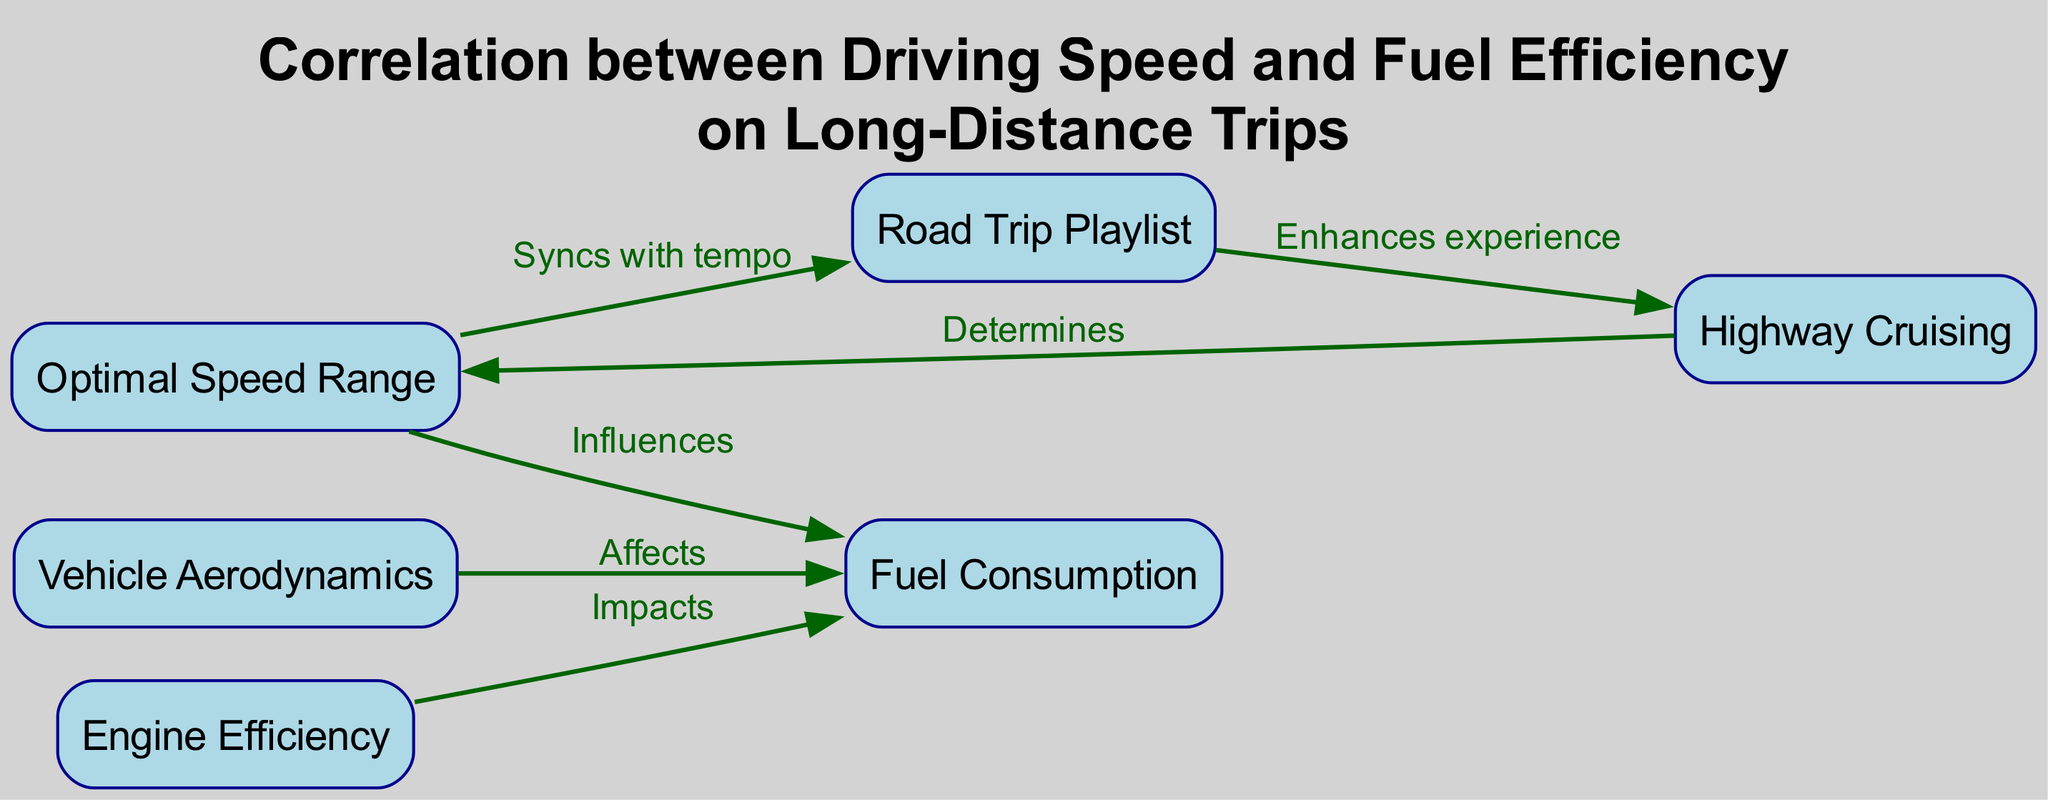What are the nodes in the diagram? The nodes in the diagram represent key concepts related to driving speed and fuel efficiency, which are: Optimal Speed Range, Fuel Consumption, Highway Cruising, Road Trip Playlist, Vehicle Aerodynamics, and Engine Efficiency.
Answer: Optimal Speed Range, Fuel Consumption, Highway Cruising, Road Trip Playlist, Vehicle Aerodynamics, Engine Efficiency How many edges are present in the diagram? The edges represent the relationships between the nodes. By counting the pairs that connect two nodes, we see there are six edges in total.
Answer: 6 What does "Highway Cruising" determine? The diagram indicates an edge from "Highway Cruising" to "Optimal Speed Range" labeled "Determines," meaning that it establishes or sets the optimal speed range.
Answer: Optimal Speed Range Which node is influenced by the "Optimal Speed Range"? The diagram shows an edge from "Optimal Speed Range" to "Fuel Consumption" labeled "Influences," indicating that the optimal speed range has an effect on fuel consumption.
Answer: Fuel Consumption What effect does "Vehicle Aerodynamics" have? "Vehicle Aerodynamics" is connected to "Fuel Consumption" by an edge labeled "Affects," showing that the aerodynamic properties of a vehicle can impact how much fuel it uses.
Answer: Affects Fuel Consumption Explain how "Road Trip Playlist" interacts with "Optimal Speed Range." "Road Trip Playlist" has an edge labeled "Syncs with tempo" that connects to "Optimal Speed Range." This indicates that the music selected for the trip helps to align with or maintain an optimal speed range while driving.
Answer: Syncs with tempo Which two nodes impact "Fuel Consumption"? The nodes that impact "Fuel Consumption" are "Vehicle Aerodynamics" and "Engine Efficiency." The diagram shows a direct connection from both these nodes to "Fuel Consumption," indicating their roles in determining fuel usage.
Answer: Vehicle Aerodynamics, Engine Efficiency What connection does "Engine Efficiency" have? "Engine Efficiency" directly impacts "Fuel Consumption" according to the diagram, as indicated by the edge labeled "Impacts." This relationship shows that the efficiency of the engine plays a crucial role in how fuel is consumed.
Answer: Impacts Fuel Consumption How does "Road Trip Playlist" enhance the experience of "Highway Cruising"? The edge from "Road Trip Playlist" to "Highway Cruising" is labeled "Enhances experience," suggesting that a well-curated playlist improves the enjoyment of driving within this context.
Answer: Enhances experience 